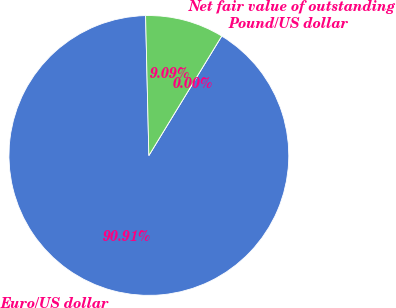Convert chart. <chart><loc_0><loc_0><loc_500><loc_500><pie_chart><fcel>Euro/US dollar<fcel>Pound/US dollar<fcel>Net fair value of outstanding<nl><fcel>90.9%<fcel>0.0%<fcel>9.09%<nl></chart> 